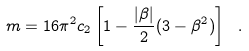Convert formula to latex. <formula><loc_0><loc_0><loc_500><loc_500>m = 1 6 \pi ^ { 2 } c _ { 2 } \left [ 1 - \frac { | \beta | } { 2 } ( 3 - \beta ^ { 2 } ) \right ] \ .</formula> 